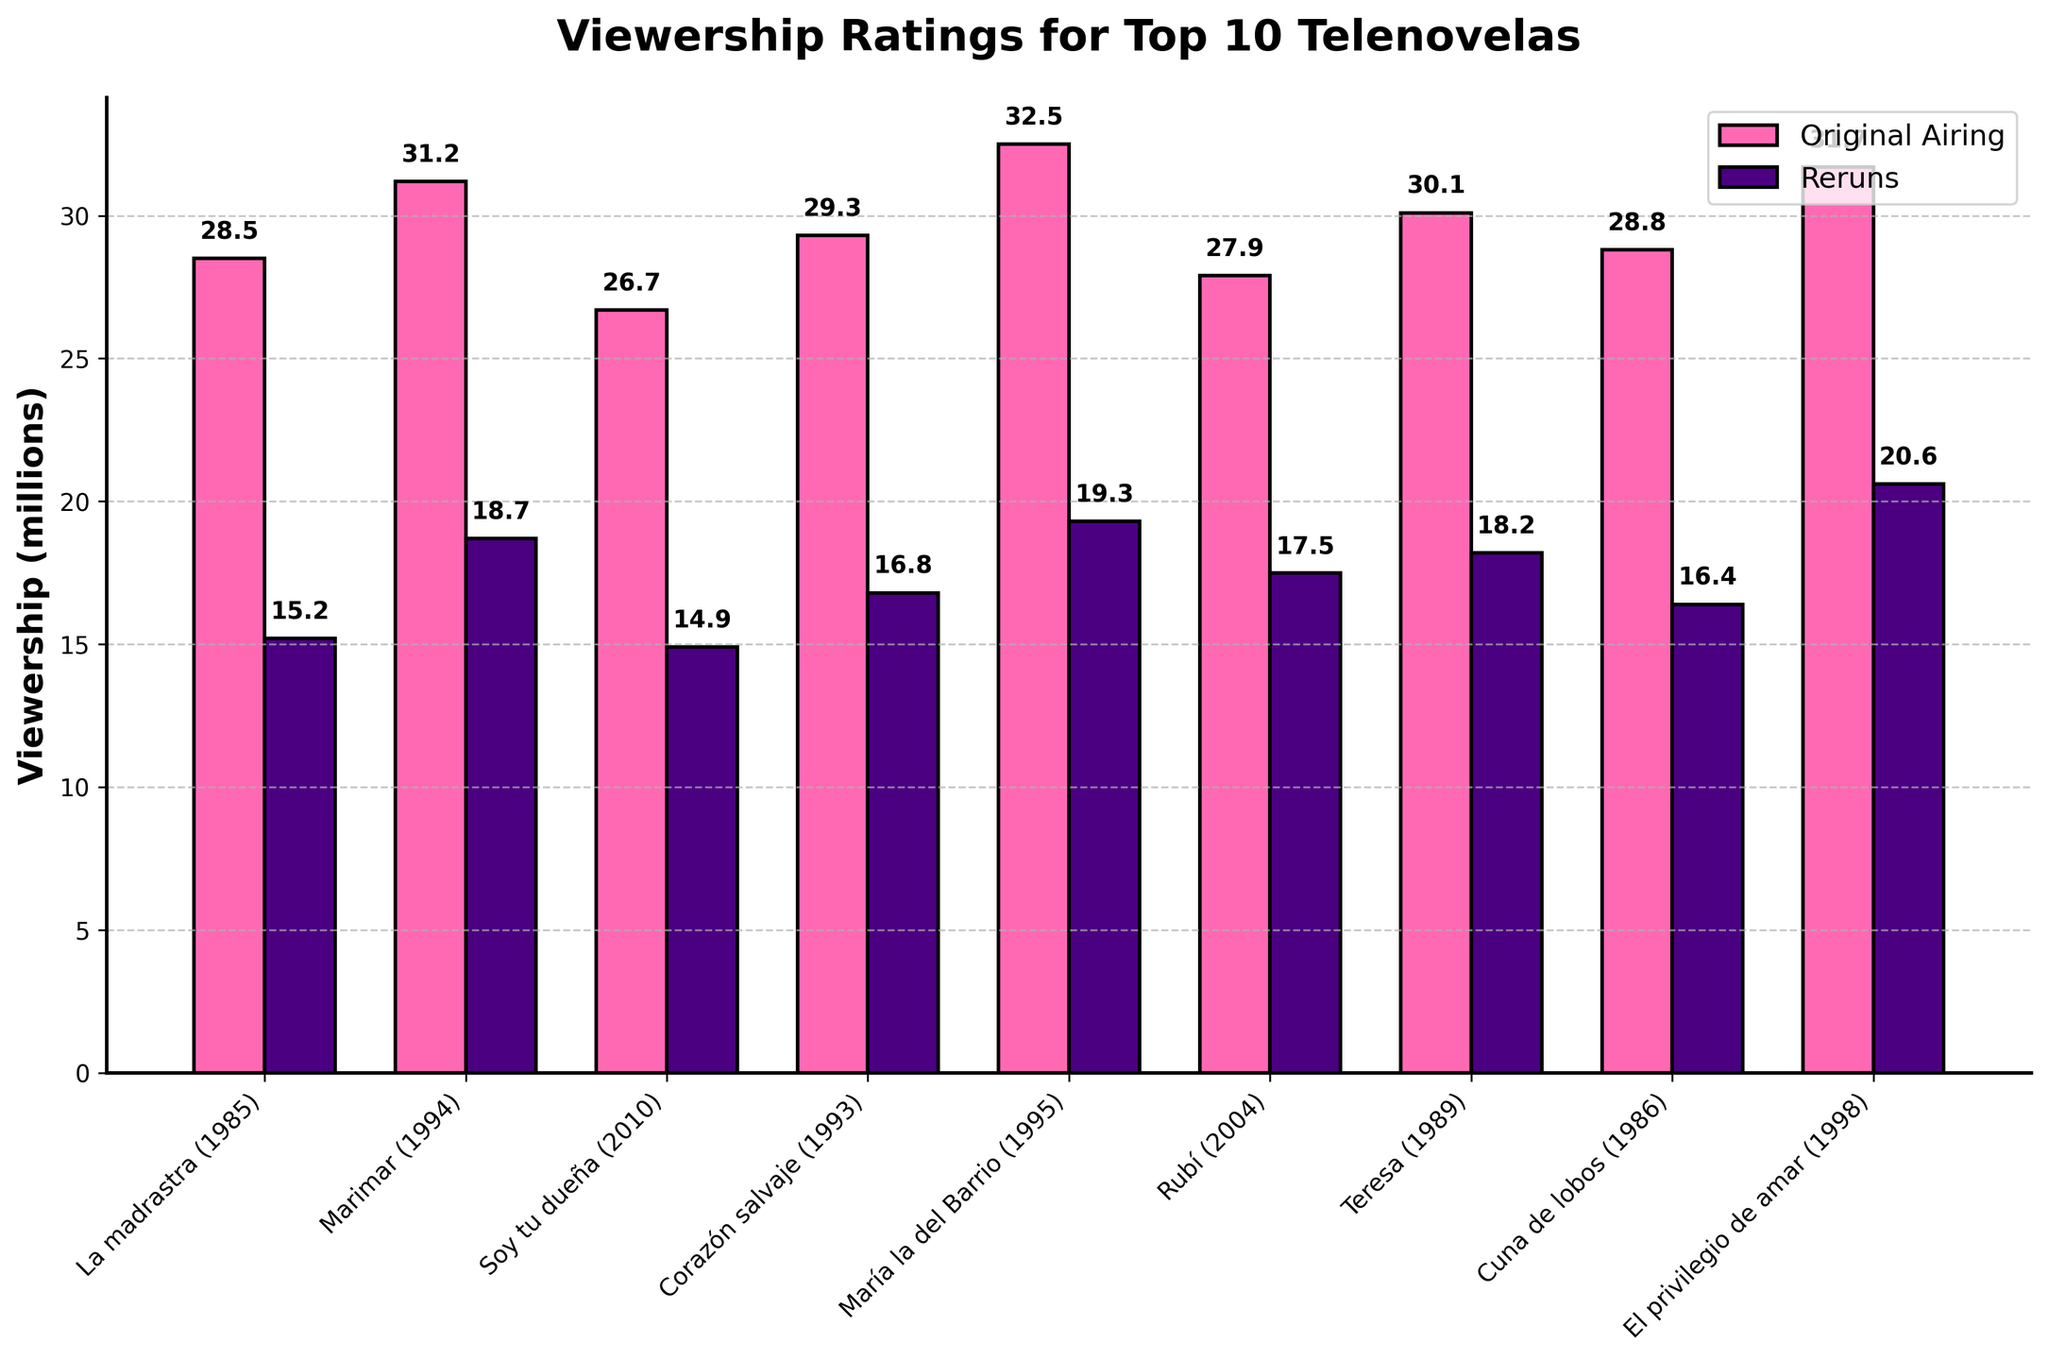what is the total viewership for both original airing and reruns of "La madrastra"? The original airing viewership for "La madrastra" (1985) is 28.5 million, and the reruns viewership is 15.2 million. To find the total viewership, sum these two values: 28.5 + 15.2 = 43.7 million.
Answer: 43.7 million Which telenovela had the highest viewership during reruns? The bars colored in purple represent reruns. "El privilegio de amar" (1998) has the highest reruns viewership at 20.6 million.
Answer: El privilegio de amar Did "Marimar" (1994) have a higher original airing viewership or reruns viewership? Compare the heights of the pink (original airing) and purple (reruns) bars for "Marimar" (1994). The original airing bar is higher at 31.2 million compared to the reruns bar at 18.7 million.
Answer: Original airing What is the average viewership for the top 3 telenovelas based on original airing? The top 3 telenovelas based on original airing are "María la del Barrio" (32.5 million), "El privilegio de amar" (31.7 million), and "Marimar" (31.2 million). Calculate the average: (32.5 + 31.7 + 31.2) / 3 = 95.4 / 3 = 31.8 million.
Answer: 31.8 million Which telenovela saw the largest drop in viewership from original airing to reruns? To find this, calculate the difference between original airing and reruns viewership for each telenovela and identify the largest drop. "La madrastra" (1985) drops from 28.5 to 15.2 million, a difference of 13.3 million, which is the largest among all.
Answer: La madrastra Compare the reruns viewership of "Rubí" (2004) and "Teresa" (1989). Which one is higher? Look at the heights of the purple bars for "Rubí" and "Teresa". The reruns viewership for "Rubí" is 17.5 million and for "Teresa" is 18.2 million.
Answer: Teresa What is the median viewership of the telenovelas during their original airing? Arrange the original airing viewership in ascending order: 26.7, 27.9, 28.5, 28.8, 29.3, 30.1, 31.2, 31.7, 32.5. The median is the middle value, which in this case (9 data points) is the 5th value: 29.3 million.
Answer: 29.3 million How much more viewership did "Cuna de lobos" (1986) get during its original airing compared to its reruns? The original airing for "Cuna de lobos" is 28.8 million, and the reruns viewership is 16.4 million. Subtract reruns from original airing: 28.8 - 16.4 = 12.4 million.
Answer: 12.4 million 